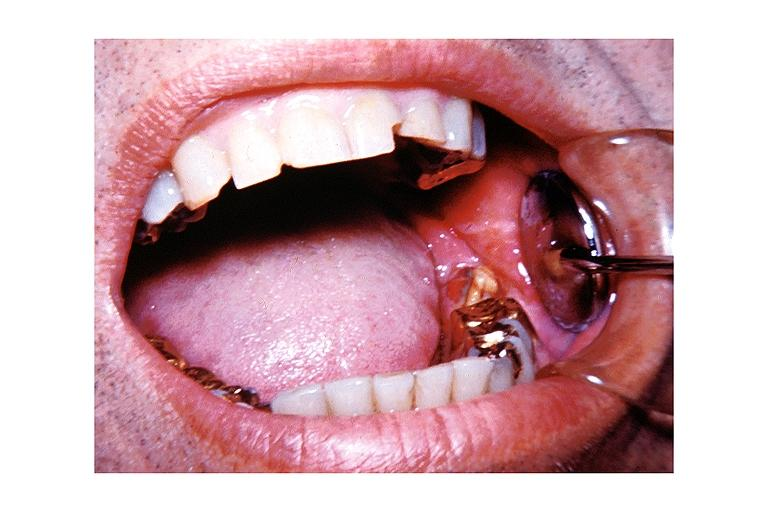what is present?
Answer the question using a single word or phrase. Oral 